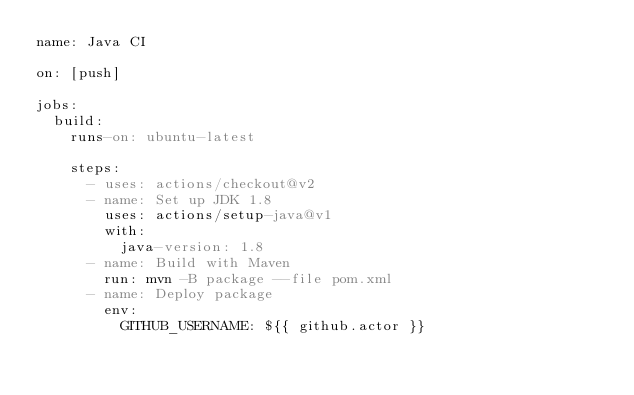Convert code to text. <code><loc_0><loc_0><loc_500><loc_500><_YAML_>name: Java CI

on: [push]

jobs:
  build:
    runs-on: ubuntu-latest

    steps:
      - uses: actions/checkout@v2
      - name: Set up JDK 1.8
        uses: actions/setup-java@v1
        with:
          java-version: 1.8
      - name: Build with Maven
        run: mvn -B package --file pom.xml
      - name: Deploy package
        env:
          GITHUB_USERNAME: ${{ github.actor }}</code> 